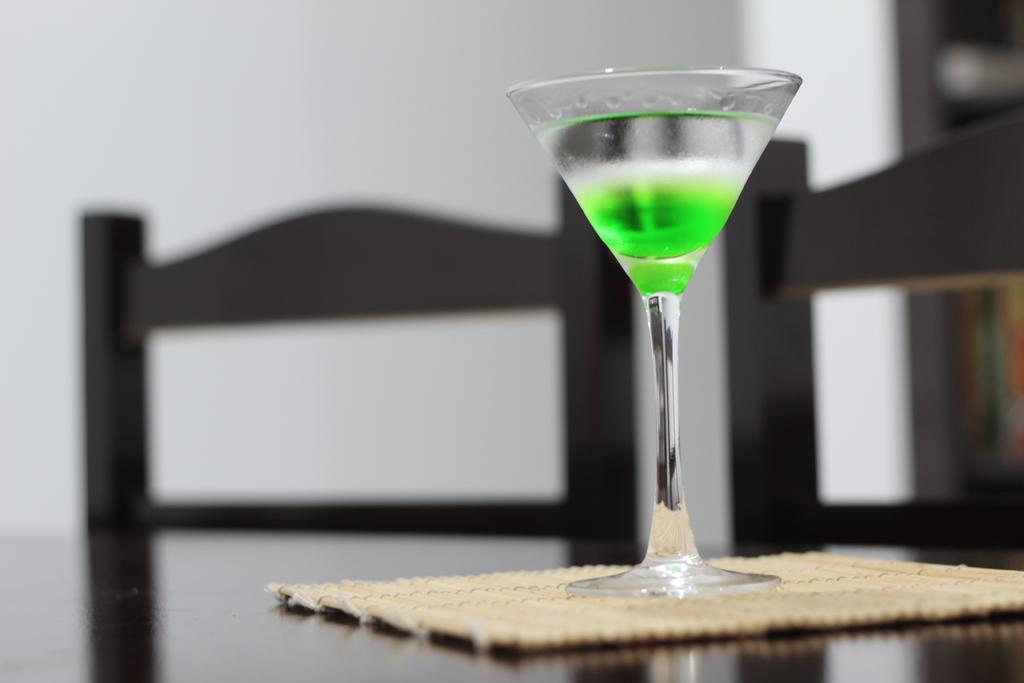What is in the glass that is visible in the image? There is a glass of juice in the image. Where is the glass of juice located? The glass of juice is placed on a table. What type of material is used for the small sheet in the image? There is a small bamboo sheet in the image. What type of furniture is visible in the image? There are chairs visible in the image. What is the background of the image? There is a wall in the image. What type of driving license does the glass of juice have in the image? The glass of juice does not have a driving license, as it is an inanimate object and cannot possess a driving license. 